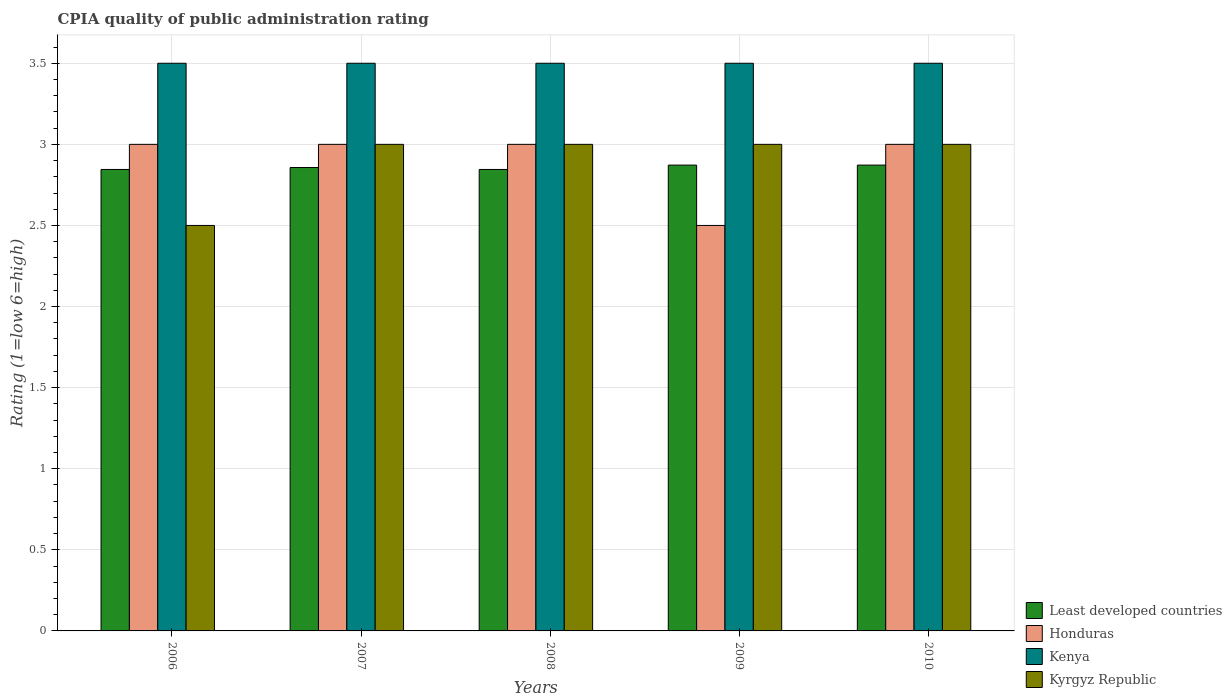Are the number of bars on each tick of the X-axis equal?
Ensure brevity in your answer.  Yes. How many bars are there on the 5th tick from the left?
Offer a terse response. 4. What is the label of the 2nd group of bars from the left?
Keep it short and to the point. 2007. In how many cases, is the number of bars for a given year not equal to the number of legend labels?
Give a very brief answer. 0. What is the CPIA rating in Least developed countries in 2007?
Your answer should be very brief. 2.86. Across all years, what is the maximum CPIA rating in Kenya?
Your answer should be compact. 3.5. Across all years, what is the minimum CPIA rating in Kyrgyz Republic?
Your response must be concise. 2.5. In which year was the CPIA rating in Kenya maximum?
Your answer should be very brief. 2006. What is the total CPIA rating in Honduras in the graph?
Your answer should be compact. 14.5. What is the difference between the CPIA rating in Honduras in 2008 and that in 2009?
Provide a short and direct response. 0.5. What is the difference between the CPIA rating in Kyrgyz Republic in 2010 and the CPIA rating in Least developed countries in 2009?
Provide a succinct answer. 0.13. What is the average CPIA rating in Kenya per year?
Give a very brief answer. 3.5. In the year 2010, what is the difference between the CPIA rating in Honduras and CPIA rating in Kyrgyz Republic?
Provide a succinct answer. 0. What is the ratio of the CPIA rating in Least developed countries in 2006 to that in 2009?
Offer a terse response. 0.99. Is the CPIA rating in Least developed countries in 2006 less than that in 2009?
Provide a short and direct response. Yes. What is the difference between the highest and the lowest CPIA rating in Honduras?
Make the answer very short. 0.5. In how many years, is the CPIA rating in Least developed countries greater than the average CPIA rating in Least developed countries taken over all years?
Give a very brief answer. 2. What does the 3rd bar from the left in 2008 represents?
Provide a succinct answer. Kenya. What does the 4th bar from the right in 2008 represents?
Keep it short and to the point. Least developed countries. How many bars are there?
Provide a succinct answer. 20. Are all the bars in the graph horizontal?
Your response must be concise. No. How many years are there in the graph?
Give a very brief answer. 5. Does the graph contain grids?
Give a very brief answer. Yes. Where does the legend appear in the graph?
Your answer should be very brief. Bottom right. How many legend labels are there?
Offer a very short reply. 4. How are the legend labels stacked?
Ensure brevity in your answer.  Vertical. What is the title of the graph?
Ensure brevity in your answer.  CPIA quality of public administration rating. What is the label or title of the X-axis?
Your answer should be compact. Years. What is the label or title of the Y-axis?
Make the answer very short. Rating (1=low 6=high). What is the Rating (1=low 6=high) in Least developed countries in 2006?
Offer a terse response. 2.85. What is the Rating (1=low 6=high) in Honduras in 2006?
Ensure brevity in your answer.  3. What is the Rating (1=low 6=high) of Kenya in 2006?
Offer a very short reply. 3.5. What is the Rating (1=low 6=high) in Least developed countries in 2007?
Keep it short and to the point. 2.86. What is the Rating (1=low 6=high) of Honduras in 2007?
Your answer should be very brief. 3. What is the Rating (1=low 6=high) in Least developed countries in 2008?
Your answer should be compact. 2.85. What is the Rating (1=low 6=high) of Kenya in 2008?
Offer a very short reply. 3.5. What is the Rating (1=low 6=high) of Kyrgyz Republic in 2008?
Your answer should be very brief. 3. What is the Rating (1=low 6=high) in Least developed countries in 2009?
Keep it short and to the point. 2.87. What is the Rating (1=low 6=high) in Least developed countries in 2010?
Make the answer very short. 2.87. What is the Rating (1=low 6=high) of Honduras in 2010?
Your response must be concise. 3. What is the Rating (1=low 6=high) of Kyrgyz Republic in 2010?
Keep it short and to the point. 3. Across all years, what is the maximum Rating (1=low 6=high) of Least developed countries?
Keep it short and to the point. 2.87. Across all years, what is the maximum Rating (1=low 6=high) of Kenya?
Give a very brief answer. 3.5. Across all years, what is the maximum Rating (1=low 6=high) of Kyrgyz Republic?
Your answer should be very brief. 3. Across all years, what is the minimum Rating (1=low 6=high) in Least developed countries?
Give a very brief answer. 2.85. Across all years, what is the minimum Rating (1=low 6=high) in Kenya?
Your response must be concise. 3.5. Across all years, what is the minimum Rating (1=low 6=high) of Kyrgyz Republic?
Offer a terse response. 2.5. What is the total Rating (1=low 6=high) of Least developed countries in the graph?
Keep it short and to the point. 14.29. What is the total Rating (1=low 6=high) in Kenya in the graph?
Provide a succinct answer. 17.5. What is the total Rating (1=low 6=high) in Kyrgyz Republic in the graph?
Keep it short and to the point. 14.5. What is the difference between the Rating (1=low 6=high) of Least developed countries in 2006 and that in 2007?
Offer a terse response. -0.01. What is the difference between the Rating (1=low 6=high) of Honduras in 2006 and that in 2007?
Your response must be concise. 0. What is the difference between the Rating (1=low 6=high) of Kenya in 2006 and that in 2007?
Your answer should be very brief. 0. What is the difference between the Rating (1=low 6=high) in Least developed countries in 2006 and that in 2008?
Your answer should be compact. 0. What is the difference between the Rating (1=low 6=high) of Honduras in 2006 and that in 2008?
Make the answer very short. 0. What is the difference between the Rating (1=low 6=high) of Kenya in 2006 and that in 2008?
Make the answer very short. 0. What is the difference between the Rating (1=low 6=high) in Least developed countries in 2006 and that in 2009?
Your response must be concise. -0.03. What is the difference between the Rating (1=low 6=high) of Honduras in 2006 and that in 2009?
Your response must be concise. 0.5. What is the difference between the Rating (1=low 6=high) in Kyrgyz Republic in 2006 and that in 2009?
Ensure brevity in your answer.  -0.5. What is the difference between the Rating (1=low 6=high) in Least developed countries in 2006 and that in 2010?
Your answer should be compact. -0.03. What is the difference between the Rating (1=low 6=high) in Honduras in 2006 and that in 2010?
Provide a succinct answer. 0. What is the difference between the Rating (1=low 6=high) of Least developed countries in 2007 and that in 2008?
Give a very brief answer. 0.01. What is the difference between the Rating (1=low 6=high) of Honduras in 2007 and that in 2008?
Provide a short and direct response. 0. What is the difference between the Rating (1=low 6=high) of Kenya in 2007 and that in 2008?
Offer a very short reply. 0. What is the difference between the Rating (1=low 6=high) of Least developed countries in 2007 and that in 2009?
Your response must be concise. -0.01. What is the difference between the Rating (1=low 6=high) of Honduras in 2007 and that in 2009?
Your answer should be very brief. 0.5. What is the difference between the Rating (1=low 6=high) of Kenya in 2007 and that in 2009?
Make the answer very short. 0. What is the difference between the Rating (1=low 6=high) in Kyrgyz Republic in 2007 and that in 2009?
Offer a very short reply. 0. What is the difference between the Rating (1=low 6=high) of Least developed countries in 2007 and that in 2010?
Provide a succinct answer. -0.01. What is the difference between the Rating (1=low 6=high) of Honduras in 2007 and that in 2010?
Provide a succinct answer. 0. What is the difference between the Rating (1=low 6=high) of Kenya in 2007 and that in 2010?
Your response must be concise. 0. What is the difference between the Rating (1=low 6=high) in Kyrgyz Republic in 2007 and that in 2010?
Provide a short and direct response. 0. What is the difference between the Rating (1=low 6=high) in Least developed countries in 2008 and that in 2009?
Ensure brevity in your answer.  -0.03. What is the difference between the Rating (1=low 6=high) in Least developed countries in 2008 and that in 2010?
Your answer should be compact. -0.03. What is the difference between the Rating (1=low 6=high) of Honduras in 2008 and that in 2010?
Provide a succinct answer. 0. What is the difference between the Rating (1=low 6=high) in Kenya in 2008 and that in 2010?
Offer a very short reply. 0. What is the difference between the Rating (1=low 6=high) in Least developed countries in 2009 and that in 2010?
Offer a terse response. 0. What is the difference between the Rating (1=low 6=high) in Kyrgyz Republic in 2009 and that in 2010?
Give a very brief answer. 0. What is the difference between the Rating (1=low 6=high) in Least developed countries in 2006 and the Rating (1=low 6=high) in Honduras in 2007?
Your answer should be very brief. -0.15. What is the difference between the Rating (1=low 6=high) in Least developed countries in 2006 and the Rating (1=low 6=high) in Kenya in 2007?
Your answer should be very brief. -0.65. What is the difference between the Rating (1=low 6=high) in Least developed countries in 2006 and the Rating (1=low 6=high) in Kyrgyz Republic in 2007?
Provide a short and direct response. -0.15. What is the difference between the Rating (1=low 6=high) of Honduras in 2006 and the Rating (1=low 6=high) of Kenya in 2007?
Offer a terse response. -0.5. What is the difference between the Rating (1=low 6=high) of Honduras in 2006 and the Rating (1=low 6=high) of Kyrgyz Republic in 2007?
Offer a terse response. 0. What is the difference between the Rating (1=low 6=high) of Least developed countries in 2006 and the Rating (1=low 6=high) of Honduras in 2008?
Ensure brevity in your answer.  -0.15. What is the difference between the Rating (1=low 6=high) of Least developed countries in 2006 and the Rating (1=low 6=high) of Kenya in 2008?
Your answer should be very brief. -0.65. What is the difference between the Rating (1=low 6=high) of Least developed countries in 2006 and the Rating (1=low 6=high) of Kyrgyz Republic in 2008?
Offer a terse response. -0.15. What is the difference between the Rating (1=low 6=high) in Honduras in 2006 and the Rating (1=low 6=high) in Kenya in 2008?
Make the answer very short. -0.5. What is the difference between the Rating (1=low 6=high) of Honduras in 2006 and the Rating (1=low 6=high) of Kyrgyz Republic in 2008?
Make the answer very short. 0. What is the difference between the Rating (1=low 6=high) in Kenya in 2006 and the Rating (1=low 6=high) in Kyrgyz Republic in 2008?
Keep it short and to the point. 0.5. What is the difference between the Rating (1=low 6=high) of Least developed countries in 2006 and the Rating (1=low 6=high) of Honduras in 2009?
Your response must be concise. 0.35. What is the difference between the Rating (1=low 6=high) in Least developed countries in 2006 and the Rating (1=low 6=high) in Kenya in 2009?
Your answer should be compact. -0.65. What is the difference between the Rating (1=low 6=high) of Least developed countries in 2006 and the Rating (1=low 6=high) of Kyrgyz Republic in 2009?
Your answer should be compact. -0.15. What is the difference between the Rating (1=low 6=high) of Honduras in 2006 and the Rating (1=low 6=high) of Kenya in 2009?
Provide a short and direct response. -0.5. What is the difference between the Rating (1=low 6=high) in Honduras in 2006 and the Rating (1=low 6=high) in Kyrgyz Republic in 2009?
Keep it short and to the point. 0. What is the difference between the Rating (1=low 6=high) in Least developed countries in 2006 and the Rating (1=low 6=high) in Honduras in 2010?
Your answer should be compact. -0.15. What is the difference between the Rating (1=low 6=high) of Least developed countries in 2006 and the Rating (1=low 6=high) of Kenya in 2010?
Offer a terse response. -0.65. What is the difference between the Rating (1=low 6=high) in Least developed countries in 2006 and the Rating (1=low 6=high) in Kyrgyz Republic in 2010?
Offer a very short reply. -0.15. What is the difference between the Rating (1=low 6=high) in Least developed countries in 2007 and the Rating (1=low 6=high) in Honduras in 2008?
Offer a very short reply. -0.14. What is the difference between the Rating (1=low 6=high) in Least developed countries in 2007 and the Rating (1=low 6=high) in Kenya in 2008?
Ensure brevity in your answer.  -0.64. What is the difference between the Rating (1=low 6=high) in Least developed countries in 2007 and the Rating (1=low 6=high) in Kyrgyz Republic in 2008?
Provide a succinct answer. -0.14. What is the difference between the Rating (1=low 6=high) of Kenya in 2007 and the Rating (1=low 6=high) of Kyrgyz Republic in 2008?
Keep it short and to the point. 0.5. What is the difference between the Rating (1=low 6=high) of Least developed countries in 2007 and the Rating (1=low 6=high) of Honduras in 2009?
Provide a succinct answer. 0.36. What is the difference between the Rating (1=low 6=high) of Least developed countries in 2007 and the Rating (1=low 6=high) of Kenya in 2009?
Provide a succinct answer. -0.64. What is the difference between the Rating (1=low 6=high) of Least developed countries in 2007 and the Rating (1=low 6=high) of Kyrgyz Republic in 2009?
Keep it short and to the point. -0.14. What is the difference between the Rating (1=low 6=high) of Honduras in 2007 and the Rating (1=low 6=high) of Kenya in 2009?
Give a very brief answer. -0.5. What is the difference between the Rating (1=low 6=high) in Honduras in 2007 and the Rating (1=low 6=high) in Kyrgyz Republic in 2009?
Ensure brevity in your answer.  0. What is the difference between the Rating (1=low 6=high) of Least developed countries in 2007 and the Rating (1=low 6=high) of Honduras in 2010?
Provide a short and direct response. -0.14. What is the difference between the Rating (1=low 6=high) in Least developed countries in 2007 and the Rating (1=low 6=high) in Kenya in 2010?
Offer a terse response. -0.64. What is the difference between the Rating (1=low 6=high) of Least developed countries in 2007 and the Rating (1=low 6=high) of Kyrgyz Republic in 2010?
Your response must be concise. -0.14. What is the difference between the Rating (1=low 6=high) of Least developed countries in 2008 and the Rating (1=low 6=high) of Honduras in 2009?
Ensure brevity in your answer.  0.35. What is the difference between the Rating (1=low 6=high) of Least developed countries in 2008 and the Rating (1=low 6=high) of Kenya in 2009?
Provide a succinct answer. -0.65. What is the difference between the Rating (1=low 6=high) in Least developed countries in 2008 and the Rating (1=low 6=high) in Kyrgyz Republic in 2009?
Your response must be concise. -0.15. What is the difference between the Rating (1=low 6=high) of Honduras in 2008 and the Rating (1=low 6=high) of Kenya in 2009?
Your answer should be compact. -0.5. What is the difference between the Rating (1=low 6=high) in Kenya in 2008 and the Rating (1=low 6=high) in Kyrgyz Republic in 2009?
Provide a succinct answer. 0.5. What is the difference between the Rating (1=low 6=high) in Least developed countries in 2008 and the Rating (1=low 6=high) in Honduras in 2010?
Your response must be concise. -0.15. What is the difference between the Rating (1=low 6=high) of Least developed countries in 2008 and the Rating (1=low 6=high) of Kenya in 2010?
Your response must be concise. -0.65. What is the difference between the Rating (1=low 6=high) of Least developed countries in 2008 and the Rating (1=low 6=high) of Kyrgyz Republic in 2010?
Offer a very short reply. -0.15. What is the difference between the Rating (1=low 6=high) of Honduras in 2008 and the Rating (1=low 6=high) of Kyrgyz Republic in 2010?
Your response must be concise. 0. What is the difference between the Rating (1=low 6=high) in Kenya in 2008 and the Rating (1=low 6=high) in Kyrgyz Republic in 2010?
Keep it short and to the point. 0.5. What is the difference between the Rating (1=low 6=high) of Least developed countries in 2009 and the Rating (1=low 6=high) of Honduras in 2010?
Provide a succinct answer. -0.13. What is the difference between the Rating (1=low 6=high) in Least developed countries in 2009 and the Rating (1=low 6=high) in Kenya in 2010?
Make the answer very short. -0.63. What is the difference between the Rating (1=low 6=high) in Least developed countries in 2009 and the Rating (1=low 6=high) in Kyrgyz Republic in 2010?
Provide a succinct answer. -0.13. What is the difference between the Rating (1=low 6=high) in Honduras in 2009 and the Rating (1=low 6=high) in Kyrgyz Republic in 2010?
Give a very brief answer. -0.5. What is the average Rating (1=low 6=high) of Least developed countries per year?
Your answer should be compact. 2.86. What is the average Rating (1=low 6=high) of Kyrgyz Republic per year?
Your response must be concise. 2.9. In the year 2006, what is the difference between the Rating (1=low 6=high) in Least developed countries and Rating (1=low 6=high) in Honduras?
Provide a short and direct response. -0.15. In the year 2006, what is the difference between the Rating (1=low 6=high) of Least developed countries and Rating (1=low 6=high) of Kenya?
Your answer should be compact. -0.65. In the year 2006, what is the difference between the Rating (1=low 6=high) in Least developed countries and Rating (1=low 6=high) in Kyrgyz Republic?
Your response must be concise. 0.35. In the year 2006, what is the difference between the Rating (1=low 6=high) of Honduras and Rating (1=low 6=high) of Kyrgyz Republic?
Your answer should be very brief. 0.5. In the year 2007, what is the difference between the Rating (1=low 6=high) in Least developed countries and Rating (1=low 6=high) in Honduras?
Provide a succinct answer. -0.14. In the year 2007, what is the difference between the Rating (1=low 6=high) of Least developed countries and Rating (1=low 6=high) of Kenya?
Offer a very short reply. -0.64. In the year 2007, what is the difference between the Rating (1=low 6=high) of Least developed countries and Rating (1=low 6=high) of Kyrgyz Republic?
Keep it short and to the point. -0.14. In the year 2007, what is the difference between the Rating (1=low 6=high) of Honduras and Rating (1=low 6=high) of Kyrgyz Republic?
Your answer should be very brief. 0. In the year 2007, what is the difference between the Rating (1=low 6=high) in Kenya and Rating (1=low 6=high) in Kyrgyz Republic?
Your answer should be very brief. 0.5. In the year 2008, what is the difference between the Rating (1=low 6=high) of Least developed countries and Rating (1=low 6=high) of Honduras?
Make the answer very short. -0.15. In the year 2008, what is the difference between the Rating (1=low 6=high) in Least developed countries and Rating (1=low 6=high) in Kenya?
Give a very brief answer. -0.65. In the year 2008, what is the difference between the Rating (1=low 6=high) of Least developed countries and Rating (1=low 6=high) of Kyrgyz Republic?
Keep it short and to the point. -0.15. In the year 2009, what is the difference between the Rating (1=low 6=high) in Least developed countries and Rating (1=low 6=high) in Honduras?
Offer a terse response. 0.37. In the year 2009, what is the difference between the Rating (1=low 6=high) in Least developed countries and Rating (1=low 6=high) in Kenya?
Offer a very short reply. -0.63. In the year 2009, what is the difference between the Rating (1=low 6=high) of Least developed countries and Rating (1=low 6=high) of Kyrgyz Republic?
Offer a terse response. -0.13. In the year 2009, what is the difference between the Rating (1=low 6=high) of Honduras and Rating (1=low 6=high) of Kyrgyz Republic?
Give a very brief answer. -0.5. In the year 2009, what is the difference between the Rating (1=low 6=high) of Kenya and Rating (1=low 6=high) of Kyrgyz Republic?
Your answer should be very brief. 0.5. In the year 2010, what is the difference between the Rating (1=low 6=high) in Least developed countries and Rating (1=low 6=high) in Honduras?
Ensure brevity in your answer.  -0.13. In the year 2010, what is the difference between the Rating (1=low 6=high) in Least developed countries and Rating (1=low 6=high) in Kenya?
Ensure brevity in your answer.  -0.63. In the year 2010, what is the difference between the Rating (1=low 6=high) of Least developed countries and Rating (1=low 6=high) of Kyrgyz Republic?
Provide a short and direct response. -0.13. In the year 2010, what is the difference between the Rating (1=low 6=high) in Honduras and Rating (1=low 6=high) in Kyrgyz Republic?
Provide a succinct answer. 0. In the year 2010, what is the difference between the Rating (1=low 6=high) of Kenya and Rating (1=low 6=high) of Kyrgyz Republic?
Your answer should be compact. 0.5. What is the ratio of the Rating (1=low 6=high) of Kenya in 2006 to that in 2007?
Keep it short and to the point. 1. What is the ratio of the Rating (1=low 6=high) in Kyrgyz Republic in 2006 to that in 2007?
Provide a short and direct response. 0.83. What is the ratio of the Rating (1=low 6=high) in Least developed countries in 2006 to that in 2008?
Ensure brevity in your answer.  1. What is the ratio of the Rating (1=low 6=high) in Kyrgyz Republic in 2006 to that in 2008?
Keep it short and to the point. 0.83. What is the ratio of the Rating (1=low 6=high) in Least developed countries in 2006 to that in 2009?
Your response must be concise. 0.99. What is the ratio of the Rating (1=low 6=high) of Kenya in 2006 to that in 2009?
Your answer should be very brief. 1. What is the ratio of the Rating (1=low 6=high) in Kyrgyz Republic in 2006 to that in 2009?
Provide a short and direct response. 0.83. What is the ratio of the Rating (1=low 6=high) in Least developed countries in 2006 to that in 2010?
Provide a succinct answer. 0.99. What is the ratio of the Rating (1=low 6=high) in Honduras in 2006 to that in 2010?
Provide a short and direct response. 1. What is the ratio of the Rating (1=low 6=high) in Kenya in 2006 to that in 2010?
Offer a very short reply. 1. What is the ratio of the Rating (1=low 6=high) of Kyrgyz Republic in 2006 to that in 2010?
Provide a succinct answer. 0.83. What is the ratio of the Rating (1=low 6=high) in Honduras in 2007 to that in 2008?
Your response must be concise. 1. What is the ratio of the Rating (1=low 6=high) in Kenya in 2007 to that in 2009?
Offer a very short reply. 1. What is the ratio of the Rating (1=low 6=high) of Kyrgyz Republic in 2007 to that in 2009?
Provide a succinct answer. 1. What is the ratio of the Rating (1=low 6=high) in Least developed countries in 2007 to that in 2010?
Keep it short and to the point. 0.99. What is the ratio of the Rating (1=low 6=high) in Kenya in 2007 to that in 2010?
Give a very brief answer. 1. What is the ratio of the Rating (1=low 6=high) of Kyrgyz Republic in 2007 to that in 2010?
Keep it short and to the point. 1. What is the ratio of the Rating (1=low 6=high) in Least developed countries in 2008 to that in 2009?
Give a very brief answer. 0.99. What is the ratio of the Rating (1=low 6=high) in Kenya in 2008 to that in 2009?
Your answer should be compact. 1. What is the ratio of the Rating (1=low 6=high) in Least developed countries in 2008 to that in 2010?
Make the answer very short. 0.99. What is the ratio of the Rating (1=low 6=high) in Honduras in 2008 to that in 2010?
Your answer should be compact. 1. What is the ratio of the Rating (1=low 6=high) of Kenya in 2008 to that in 2010?
Ensure brevity in your answer.  1. What is the ratio of the Rating (1=low 6=high) of Kyrgyz Republic in 2008 to that in 2010?
Ensure brevity in your answer.  1. What is the ratio of the Rating (1=low 6=high) in Least developed countries in 2009 to that in 2010?
Your answer should be very brief. 1. What is the ratio of the Rating (1=low 6=high) of Honduras in 2009 to that in 2010?
Keep it short and to the point. 0.83. What is the ratio of the Rating (1=low 6=high) in Kenya in 2009 to that in 2010?
Your response must be concise. 1. What is the ratio of the Rating (1=low 6=high) of Kyrgyz Republic in 2009 to that in 2010?
Offer a very short reply. 1. What is the difference between the highest and the second highest Rating (1=low 6=high) in Honduras?
Give a very brief answer. 0. What is the difference between the highest and the second highest Rating (1=low 6=high) in Kenya?
Provide a short and direct response. 0. What is the difference between the highest and the lowest Rating (1=low 6=high) of Least developed countries?
Ensure brevity in your answer.  0.03. What is the difference between the highest and the lowest Rating (1=low 6=high) of Kenya?
Your response must be concise. 0. 